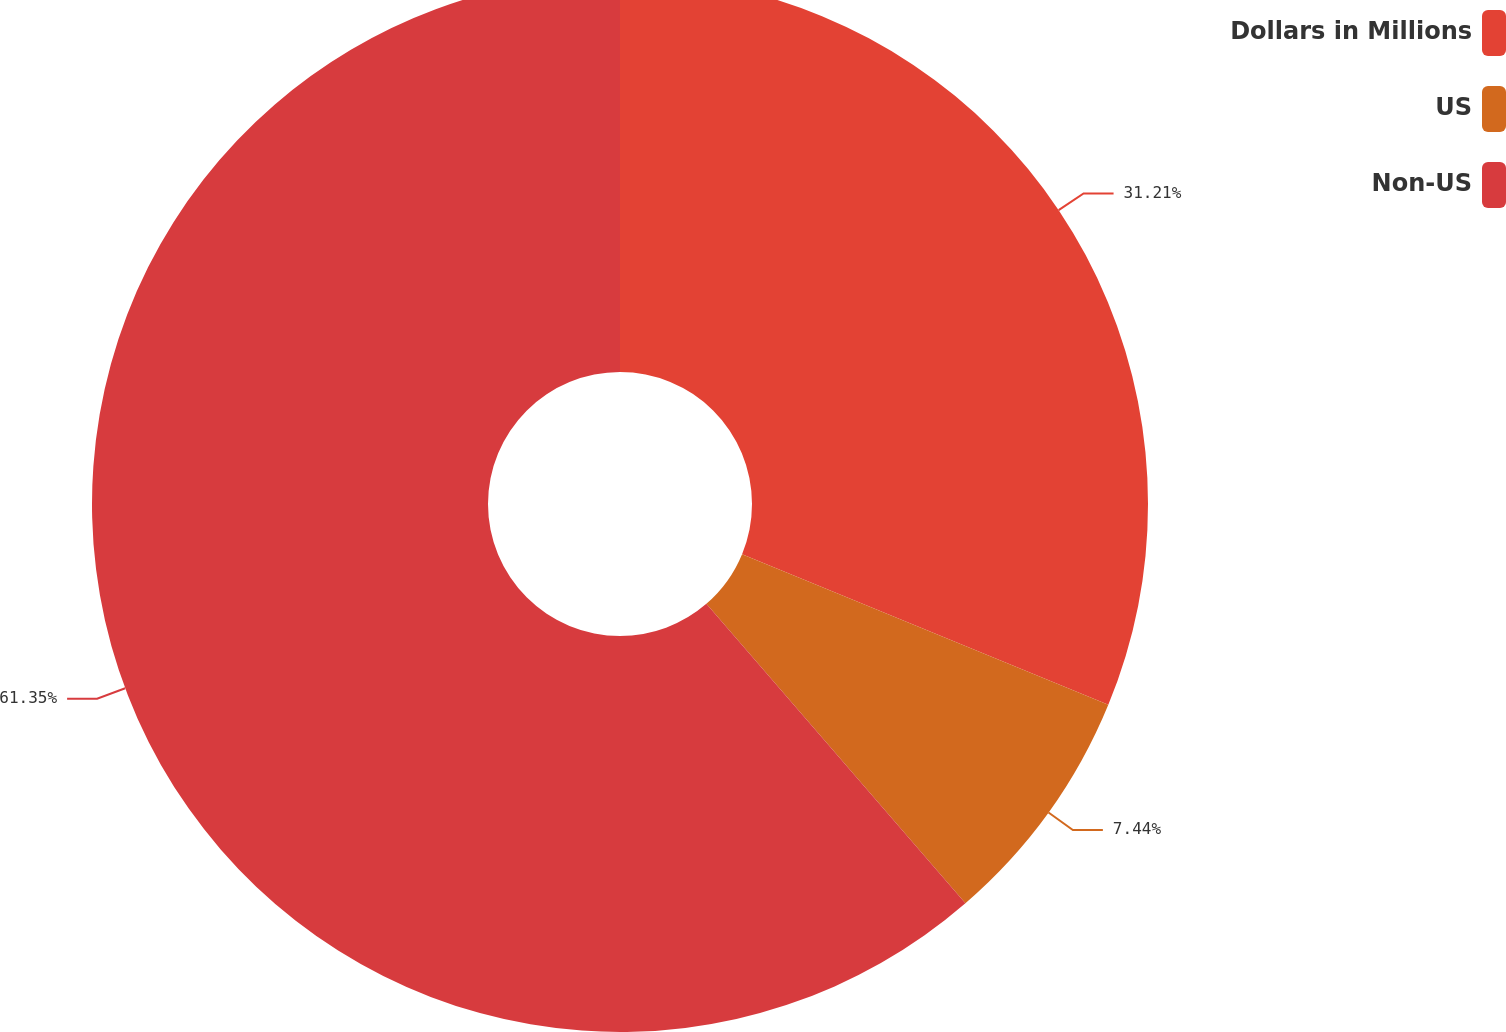Convert chart. <chart><loc_0><loc_0><loc_500><loc_500><pie_chart><fcel>Dollars in Millions<fcel>US<fcel>Non-US<nl><fcel>31.21%<fcel>7.44%<fcel>61.35%<nl></chart> 